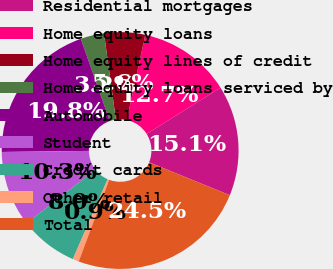<chart> <loc_0><loc_0><loc_500><loc_500><pie_chart><fcel>Residential mortgages<fcel>Home equity loans<fcel>Home equity lines of credit<fcel>Home equity loans serviced by<fcel>Automobile<fcel>Student<fcel>Credit cards<fcel>Other retail<fcel>Total<nl><fcel>15.06%<fcel>12.69%<fcel>5.58%<fcel>3.21%<fcel>19.8%<fcel>10.32%<fcel>7.95%<fcel>0.85%<fcel>24.53%<nl></chart> 